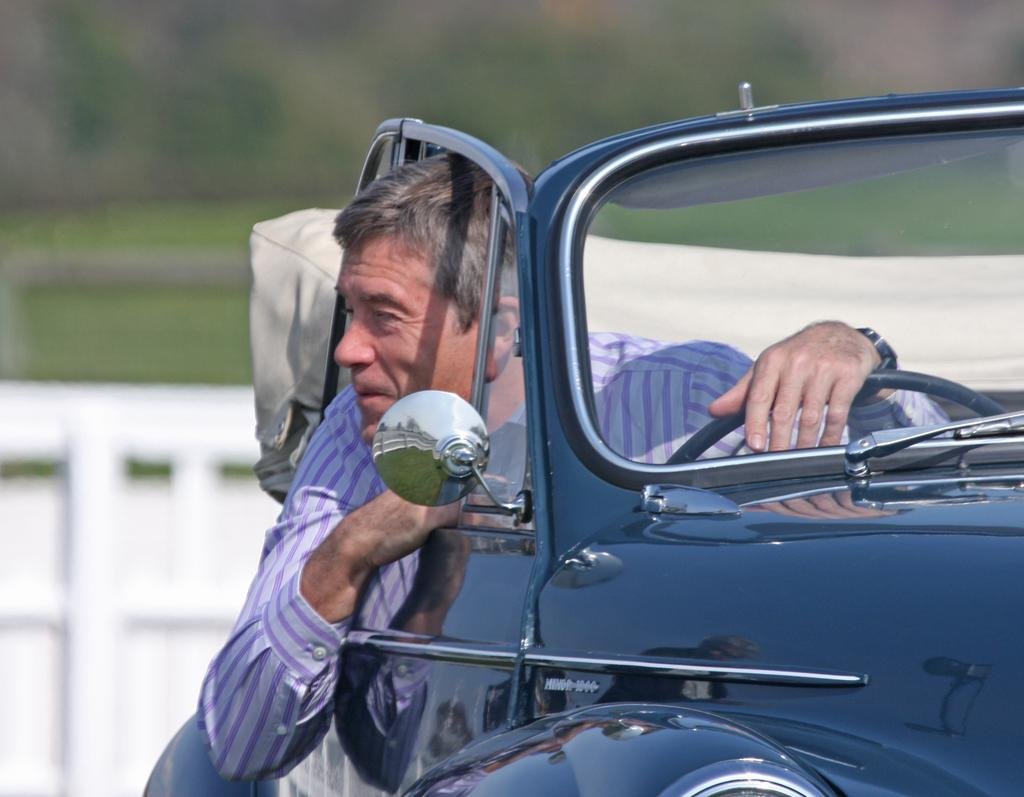Who is the main subject in the image? There is an old man in the image. What is the old man wearing? The old man is wearing a purple striped shirt. What is the old man doing in the image? The old man is driving a vintage black color car. What type of art can be seen hanging on the wall in the image? There is no mention of any art or wall in the provided facts, so we cannot answer this question. 